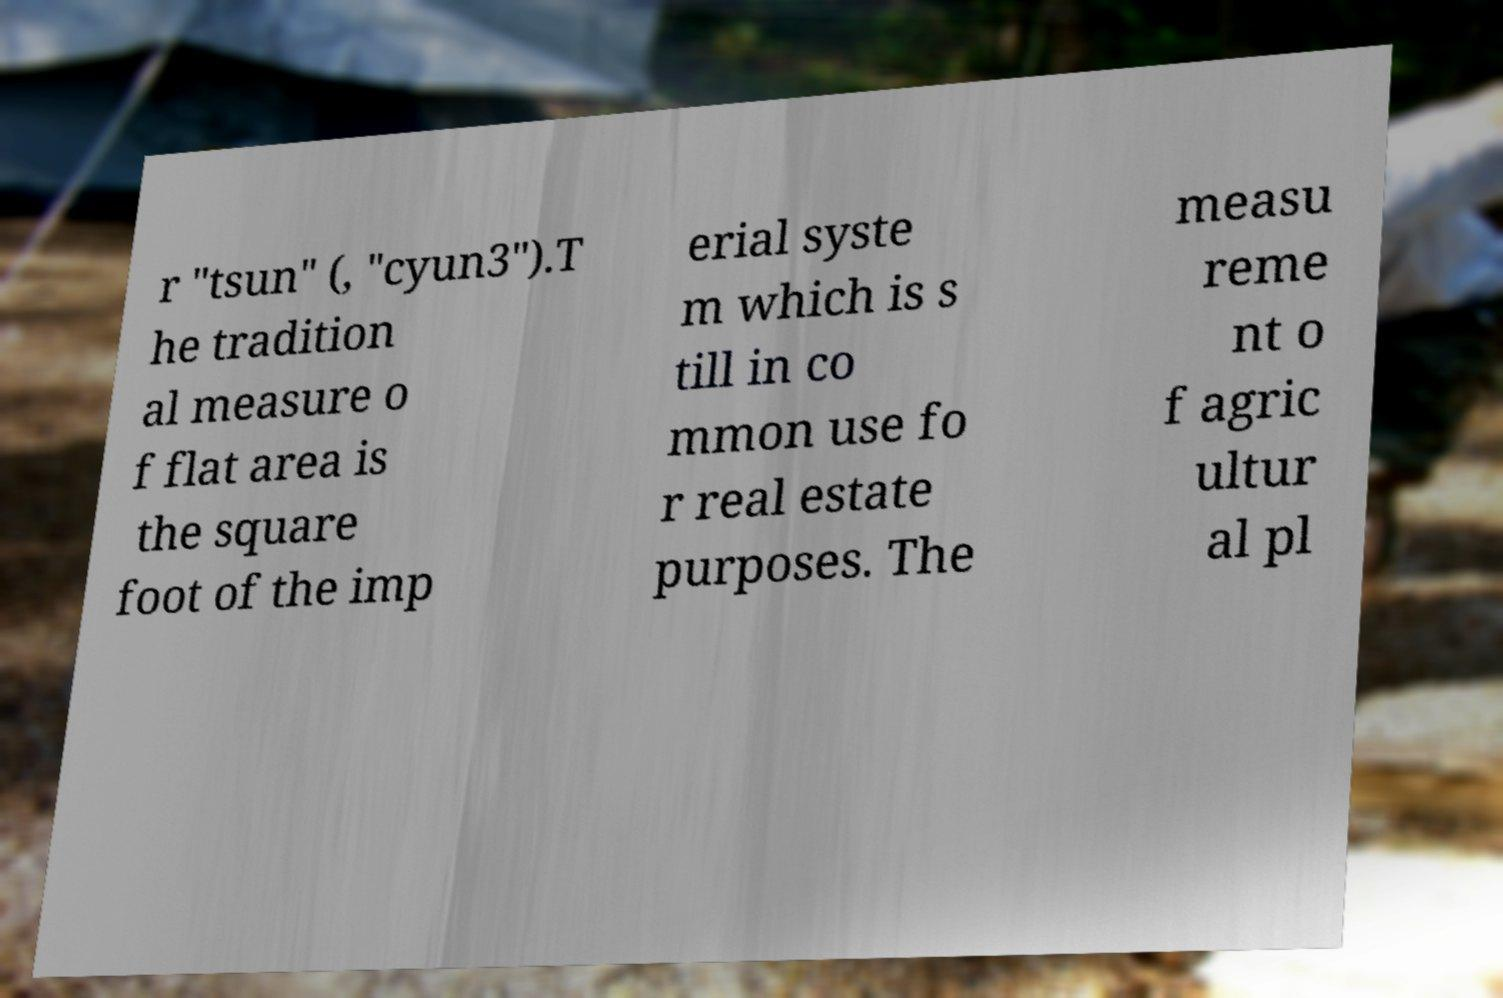Please identify and transcribe the text found in this image. r "tsun" (, "cyun3").T he tradition al measure o f flat area is the square foot of the imp erial syste m which is s till in co mmon use fo r real estate purposes. The measu reme nt o f agric ultur al pl 